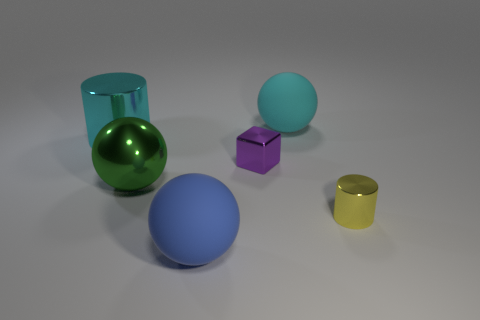There is a metallic object that is behind the metallic ball and on the right side of the cyan cylinder; what is its size?
Ensure brevity in your answer.  Small. Is there any other thing that is the same color as the small metal block?
Make the answer very short. No. There is a big green thing that is made of the same material as the tiny purple cube; what is its shape?
Make the answer very short. Sphere. Is the shape of the cyan shiny thing the same as the tiny shiny object that is on the left side of the small yellow object?
Make the answer very short. No. There is a cyan object that is right of the metallic cylinder on the left side of the blue matte ball; what is its material?
Your response must be concise. Rubber. Are there the same number of cyan metallic objects that are behind the blue sphere and big cyan cylinders?
Your answer should be compact. Yes. Is there any other thing that is the same material as the cyan sphere?
Offer a terse response. Yes. Does the big object in front of the small yellow shiny cylinder have the same color as the thing left of the green metal ball?
Your answer should be compact. No. What number of things are both right of the tiny purple cube and in front of the cyan shiny object?
Your answer should be compact. 1. What number of other things are the same shape as the big cyan metal object?
Make the answer very short. 1. 